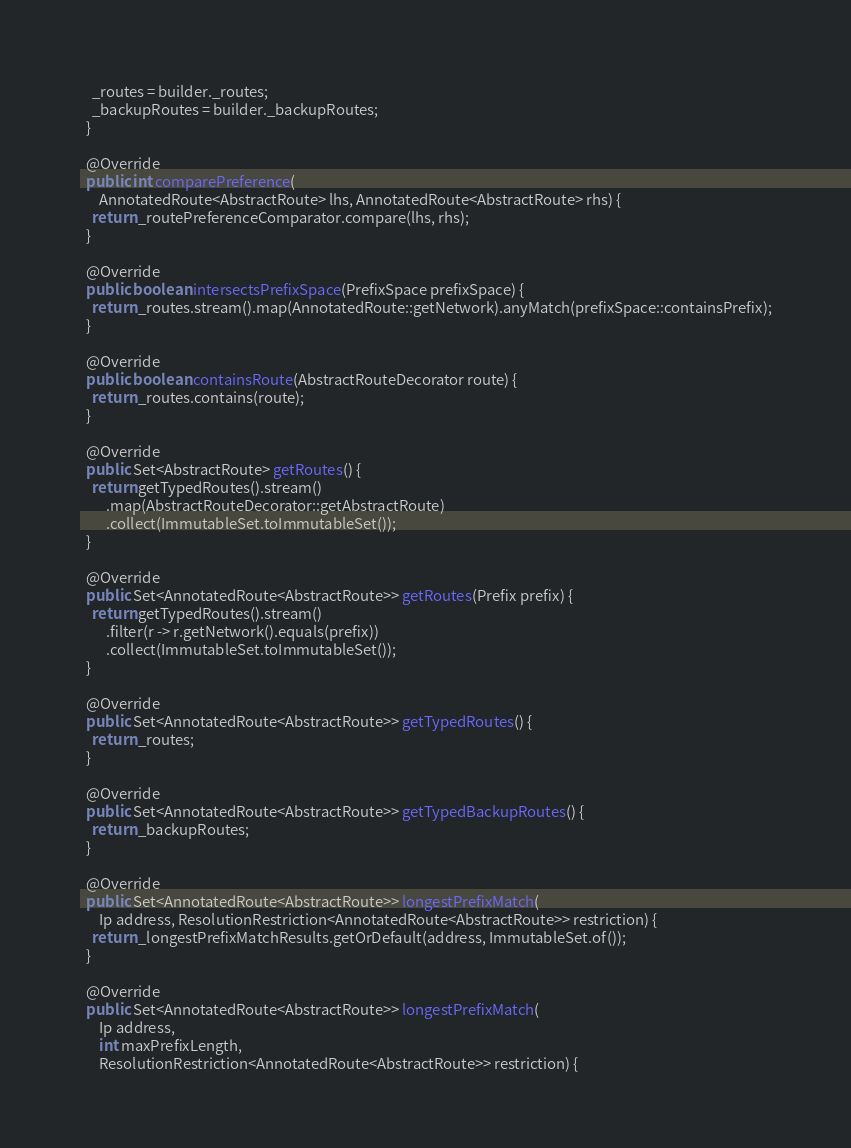<code> <loc_0><loc_0><loc_500><loc_500><_Java_>    _routes = builder._routes;
    _backupRoutes = builder._backupRoutes;
  }

  @Override
  public int comparePreference(
      AnnotatedRoute<AbstractRoute> lhs, AnnotatedRoute<AbstractRoute> rhs) {
    return _routePreferenceComparator.compare(lhs, rhs);
  }

  @Override
  public boolean intersectsPrefixSpace(PrefixSpace prefixSpace) {
    return _routes.stream().map(AnnotatedRoute::getNetwork).anyMatch(prefixSpace::containsPrefix);
  }

  @Override
  public boolean containsRoute(AbstractRouteDecorator route) {
    return _routes.contains(route);
  }

  @Override
  public Set<AbstractRoute> getRoutes() {
    return getTypedRoutes().stream()
        .map(AbstractRouteDecorator::getAbstractRoute)
        .collect(ImmutableSet.toImmutableSet());
  }

  @Override
  public Set<AnnotatedRoute<AbstractRoute>> getRoutes(Prefix prefix) {
    return getTypedRoutes().stream()
        .filter(r -> r.getNetwork().equals(prefix))
        .collect(ImmutableSet.toImmutableSet());
  }

  @Override
  public Set<AnnotatedRoute<AbstractRoute>> getTypedRoutes() {
    return _routes;
  }

  @Override
  public Set<AnnotatedRoute<AbstractRoute>> getTypedBackupRoutes() {
    return _backupRoutes;
  }

  @Override
  public Set<AnnotatedRoute<AbstractRoute>> longestPrefixMatch(
      Ip address, ResolutionRestriction<AnnotatedRoute<AbstractRoute>> restriction) {
    return _longestPrefixMatchResults.getOrDefault(address, ImmutableSet.of());
  }

  @Override
  public Set<AnnotatedRoute<AbstractRoute>> longestPrefixMatch(
      Ip address,
      int maxPrefixLength,
      ResolutionRestriction<AnnotatedRoute<AbstractRoute>> restriction) {</code> 